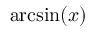Convert formula to latex. <formula><loc_0><loc_0><loc_500><loc_500>\arcsin ( x )</formula> 